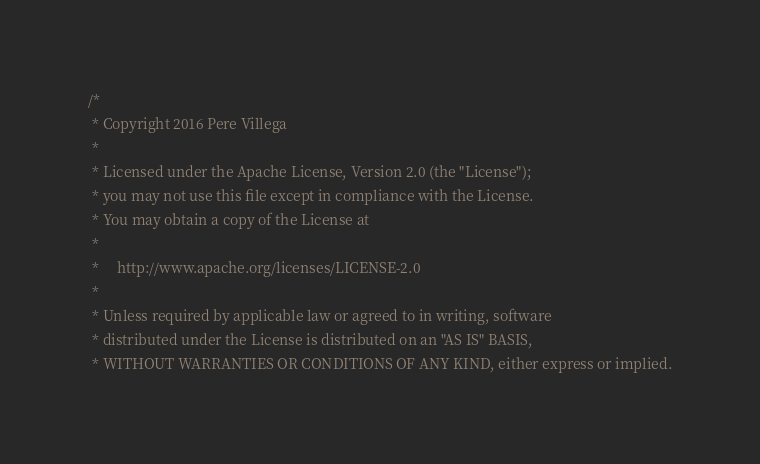<code> <loc_0><loc_0><loc_500><loc_500><_Scala_>/*
 * Copyright 2016 Pere Villega
 *
 * Licensed under the Apache License, Version 2.0 (the "License");
 * you may not use this file except in compliance with the License.
 * You may obtain a copy of the License at
 *
 *     http://www.apache.org/licenses/LICENSE-2.0
 *
 * Unless required by applicable law or agreed to in writing, software
 * distributed under the License is distributed on an "AS IS" BASIS,
 * WITHOUT WARRANTIES OR CONDITIONS OF ANY KIND, either express or implied.</code> 